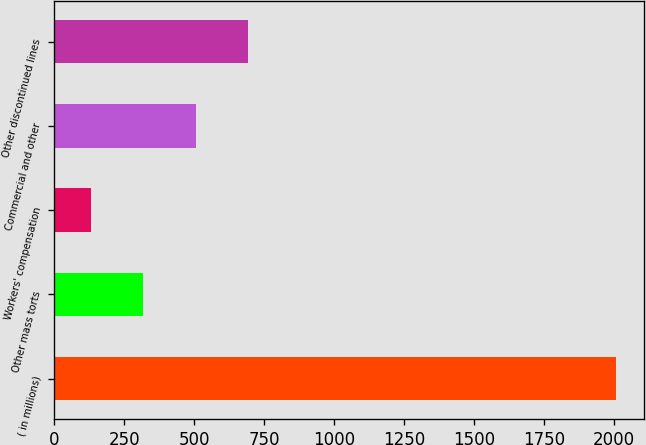<chart> <loc_0><loc_0><loc_500><loc_500><bar_chart><fcel>( in millions)<fcel>Other mass torts<fcel>Workers' compensation<fcel>Commercial and other<fcel>Other discontinued lines<nl><fcel>2008<fcel>317.8<fcel>130<fcel>505.6<fcel>693.4<nl></chart> 